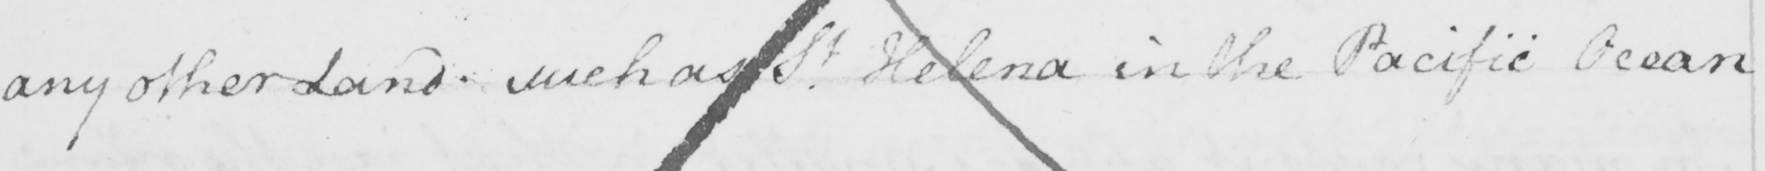Please provide the text content of this handwritten line. any other Land . such as S.t Helena in the Pacific Ocean 